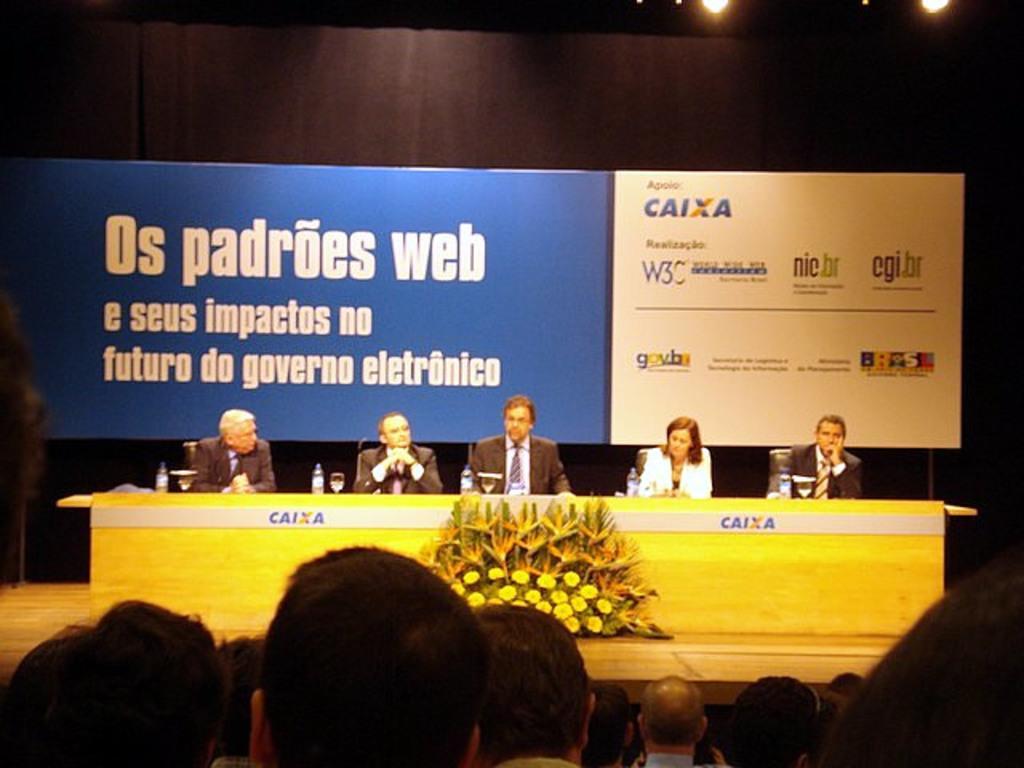How would you summarize this image in a sentence or two? In this image I can see group of people sitting on the chairs, in front I can see few microphones, glasses on the table. Background I can see a board in blue and white color attached to the black color curtain. 